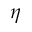Convert formula to latex. <formula><loc_0><loc_0><loc_500><loc_500>\eta</formula> 